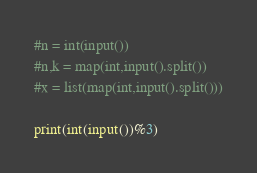Convert code to text. <code><loc_0><loc_0><loc_500><loc_500><_Python_>#n = int(input())
#n,k = map(int,input().split())
#x = list(map(int,input().split()))

print(int(input())%3) 
</code> 